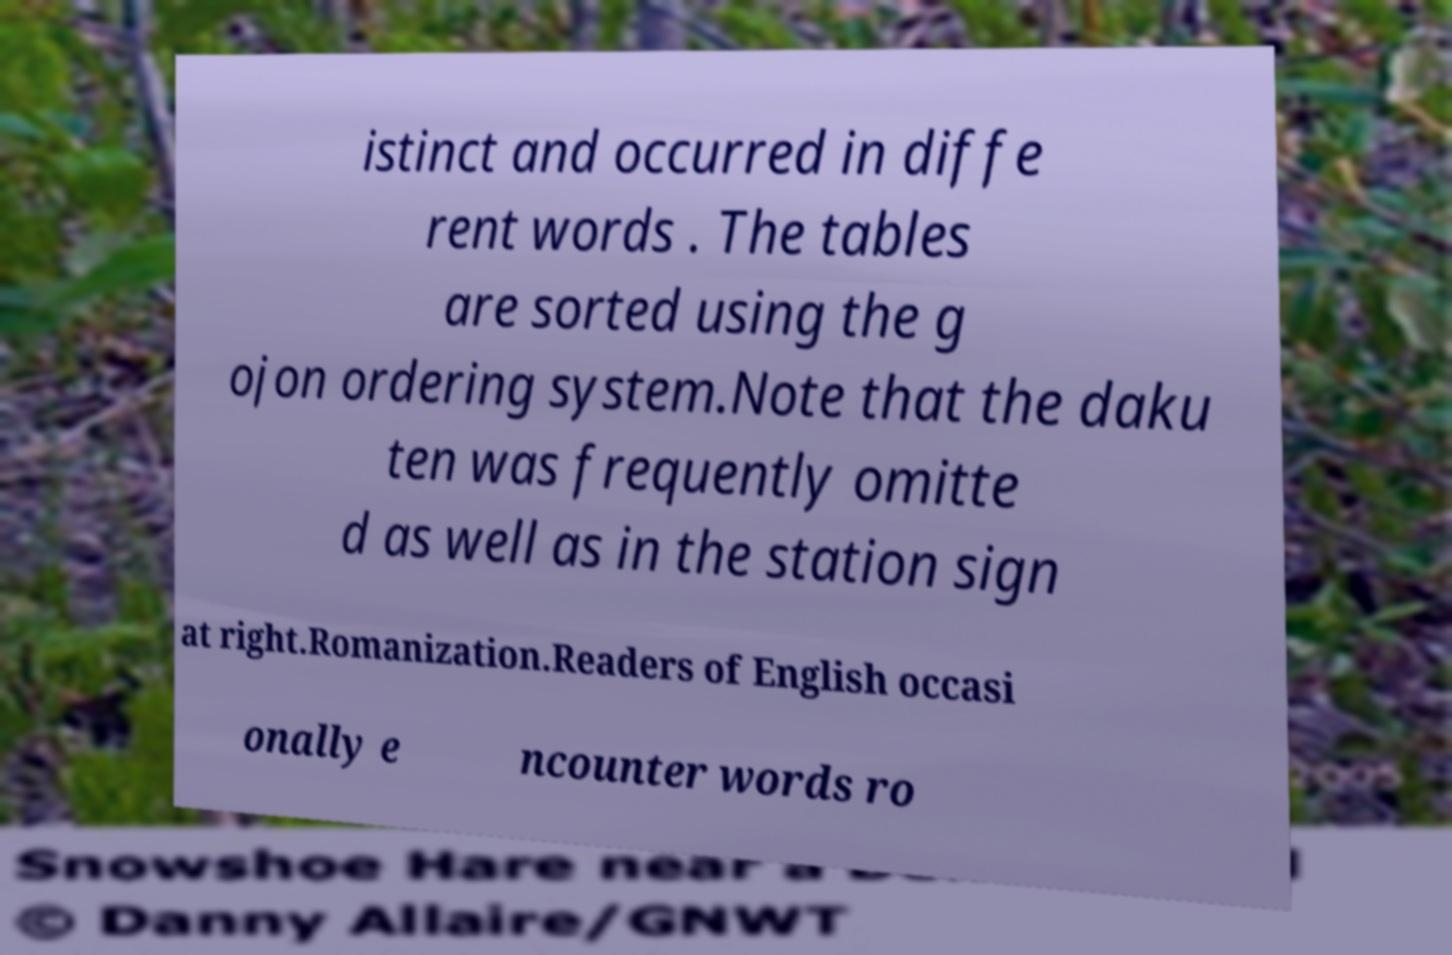There's text embedded in this image that I need extracted. Can you transcribe it verbatim? istinct and occurred in diffe rent words . The tables are sorted using the g ojon ordering system.Note that the daku ten was frequently omitte d as well as in the station sign at right.Romanization.Readers of English occasi onally e ncounter words ro 